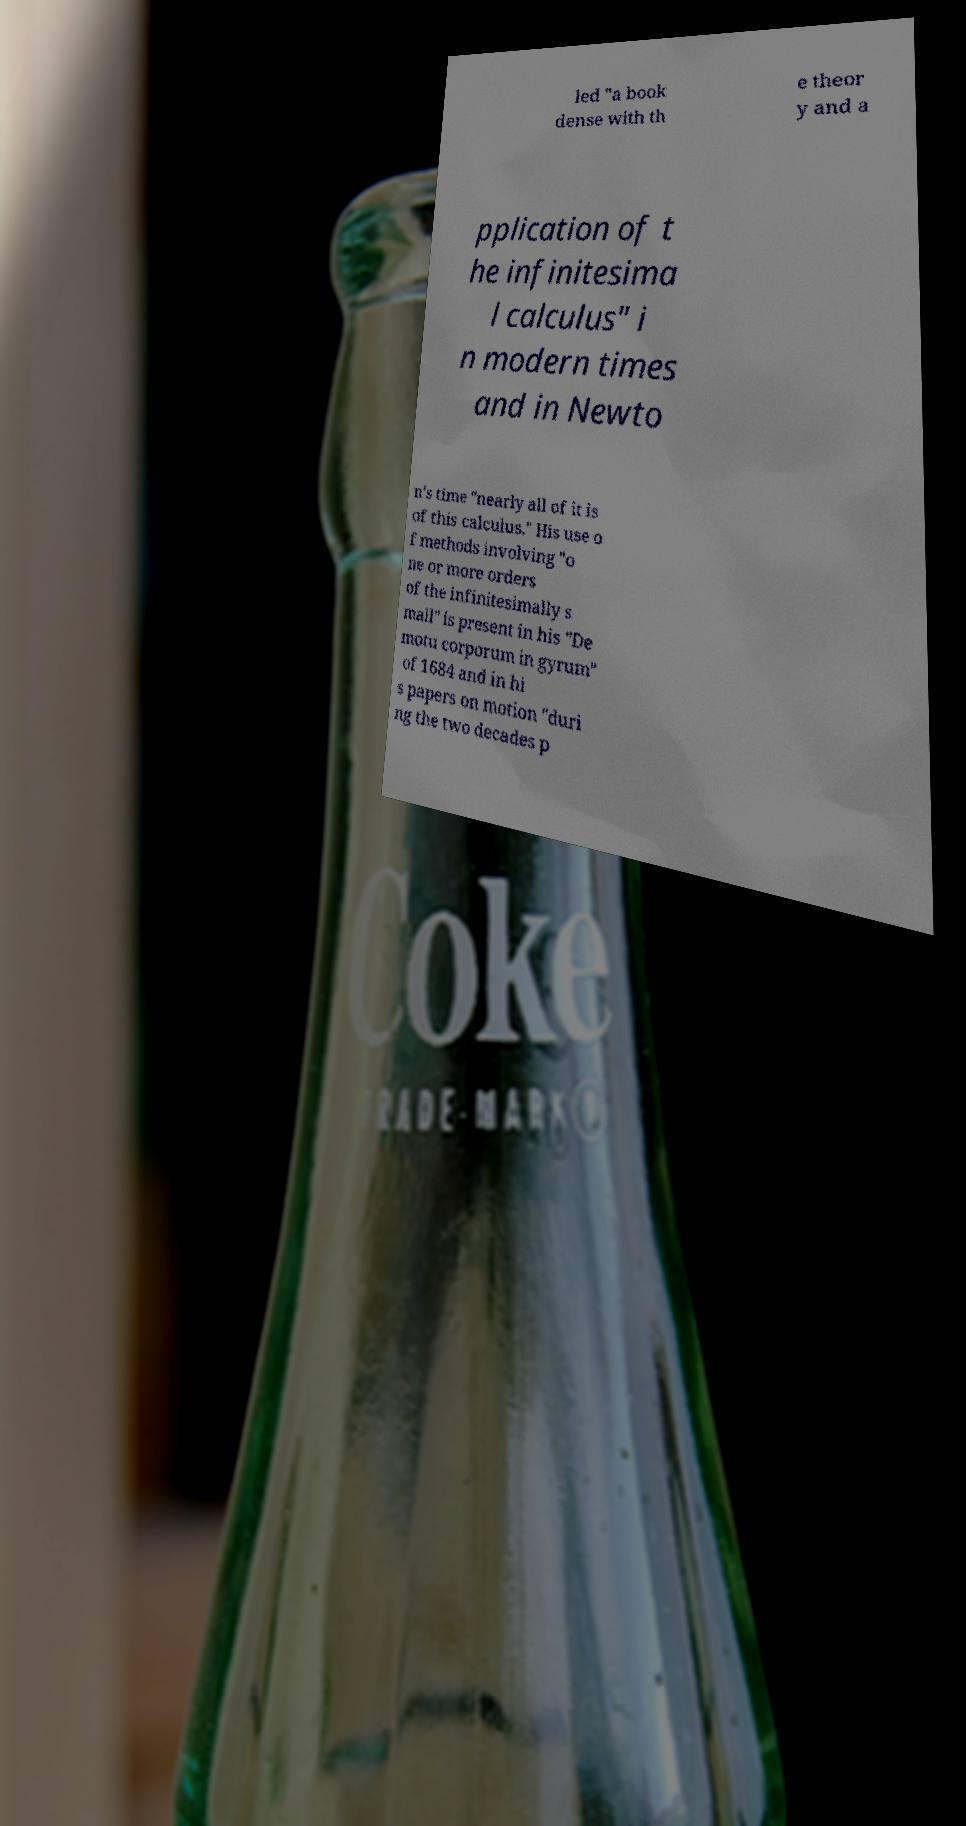Could you extract and type out the text from this image? led "a book dense with th e theor y and a pplication of t he infinitesima l calculus" i n modern times and in Newto n's time "nearly all of it is of this calculus." His use o f methods involving "o ne or more orders of the infinitesimally s mall" is present in his "De motu corporum in gyrum" of 1684 and in hi s papers on motion "duri ng the two decades p 